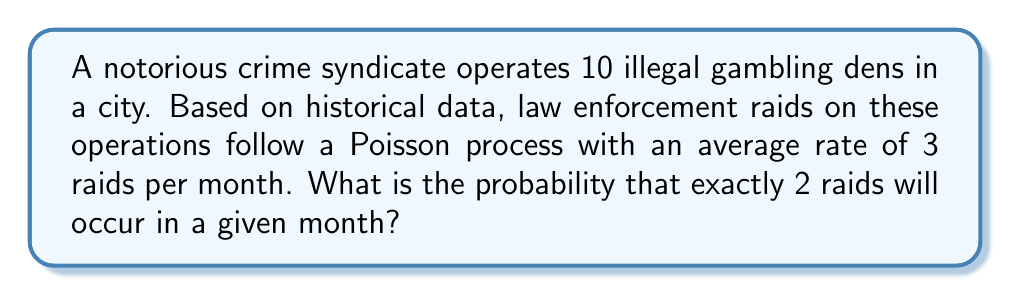Teach me how to tackle this problem. To solve this problem, we'll use the Poisson distribution formula:

$$P(X = k) = \frac{e^{-\lambda} \lambda^k}{k!}$$

Where:
$\lambda$ = average rate of events (raids) per time period
$k$ = number of events we're calculating the probability for
$e$ = Euler's number (approximately 2.71828)

Given:
$\lambda = 3$ raids per month
$k = 2$ raids

Step 1: Substitute the values into the formula:

$$P(X = 2) = \frac{e^{-3} 3^2}{2!}$$

Step 2: Simplify the expression:

$$P(X = 2) = \frac{e^{-3} \cdot 9}{2}$$

Step 3: Calculate $e^{-3}$:
$e^{-3} \approx 0.0497871$

Step 4: Multiply the numerator:
$0.0497871 \cdot 9 = 0.4480839$

Step 5: Divide by 2:
$0.4480839 / 2 = 0.22404195$

Therefore, the probability of exactly 2 raids occurring in a given month is approximately 0.22404195 or about 22.4%.
Answer: 0.22404195 